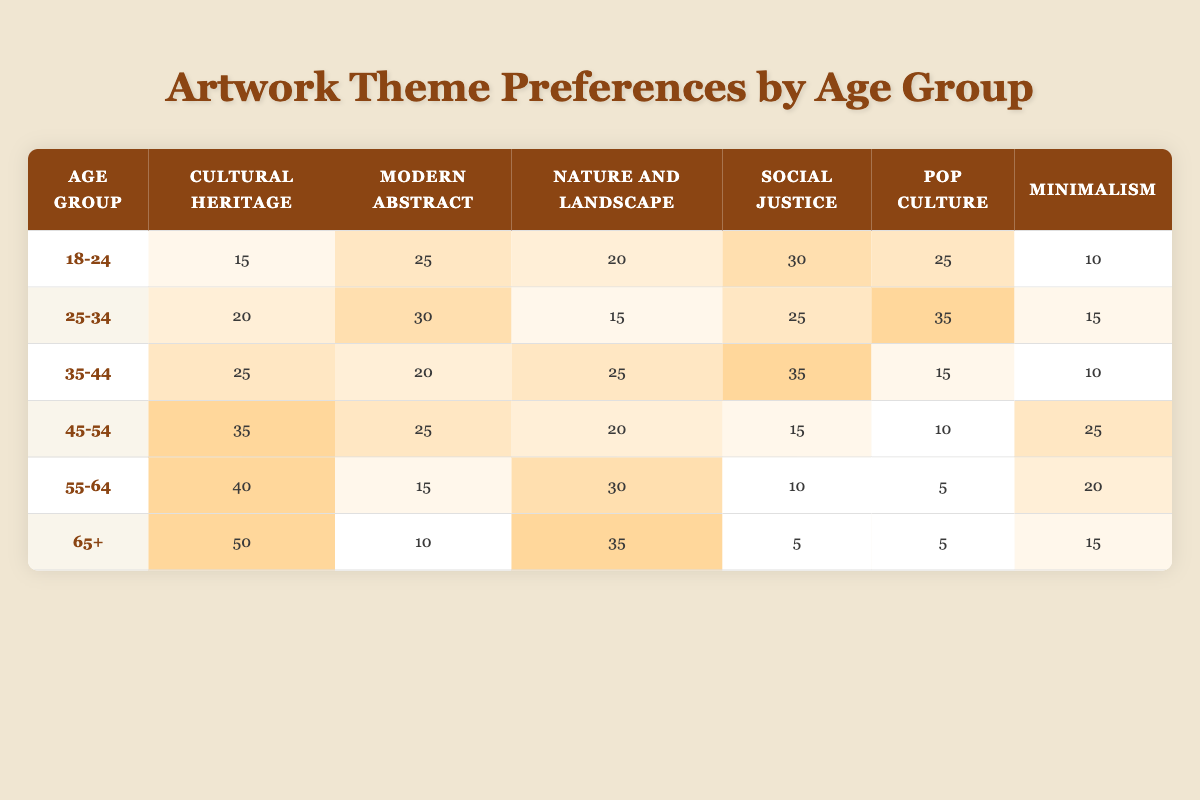What is the preference for "Minimalism" in the age group 25-34? According to the table, the preference for "Minimalism" in the age group 25-34 is 15.
Answer: 15 Which age group shows the highest preference for "Cultural Heritage"? By scanning the first column for "Cultural Heritage," it is evident that the age group 65+ has the highest preference with a score of 50.
Answer: 65+ Is "Pop Culture" preferred more by the age group 45-54 than by the age group 35-44? In the table, the age group 45-54 has a preference score of 10 for "Pop Culture," while the age group 35-44 has a score of 15. Therefore, the statement is false.
Answer: No What is the total preference score for "Nature and Landscape" across all age groups? To find the total for "Nature and Landscape," we sum the scores from each age group: 20 + 15 + 25 + 20 + 30 + 35 = 145.
Answer: 145 Which artwork theme has the least preference in the age group 55-64? The age group 55-64 has preferences of 40 for "Cultural Heritage," 15 for "Modern Abstract," 30 for "Nature and Landscape," 10 for "Social Justice," 5 for "Pop Culture," and 20 for "Minimalism." The least preferred theme is "Pop Culture" with a score of 5.
Answer: Pop Culture Is the preference for "Social Justice" higher in the age group 18-24 than in the age group 45-54? The preference for "Social Justice" in 18-24 is 30, while in 45-54 it is 15. Since 30 is greater than 15, the statement is true.
Answer: Yes What percentage of the total preference scores does "Modern Abstract" represent in the age group 35-44, given that the total preferences for this age group add up to 100? The score for "Modern Abstract" in the age group 35-44 is 20. The total for this age group is 20 + 25 + 25 + 35 + 15 + 10 = 100. Hence, percentage = (20/100) * 100 = 20%.
Answer: 20% What is the difference in preference scores for "Nature and Landscape" between the age groups 25-34 and 55-64? The score for "Nature and Landscape" in the age group 25-34 is 15, and in 55-64 it is 30. The difference is 30 - 15 = 15.
Answer: 15 Does the age group 65+ have a higher or lower preference for "Minimalism" compared to the age group 18-24? The score for "Minimalism" in the age group 65+ is 15, while in the age group 18-24 it is 10. Since 15 is greater than 10, the age group 65+ has a higher preference.
Answer: Higher 